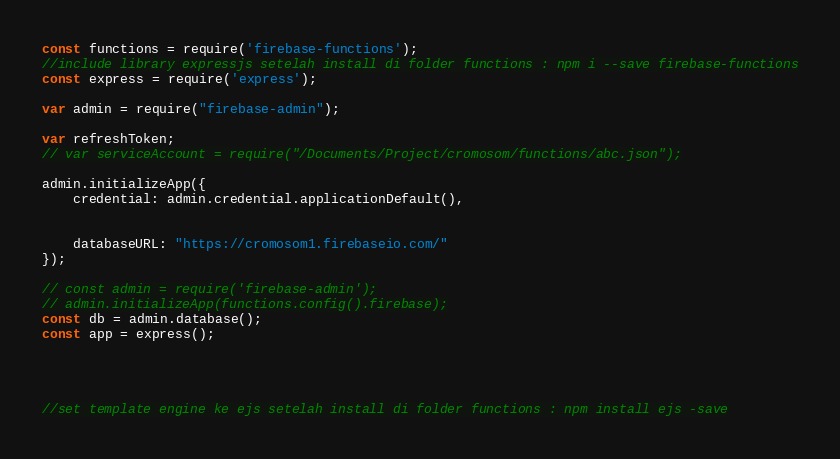<code> <loc_0><loc_0><loc_500><loc_500><_JavaScript_>const functions = require('firebase-functions');
//include library expressjs setelah install di folder functions : npm i --save firebase-functions
const express = require('express');

var admin = require("firebase-admin");

var refreshToken;
// var serviceAccount = require("/Documents/Project/cromosom/functions/abc.json");

admin.initializeApp({
    credential: admin.credential.applicationDefault(),


    databaseURL: "https://cromosom1.firebaseio.com/"
});

// const admin = require('firebase-admin');
// admin.initializeApp(functions.config().firebase);
const db = admin.database();
const app = express();




//set template engine ke ejs setelah install di folder functions : npm install ejs -save</code> 